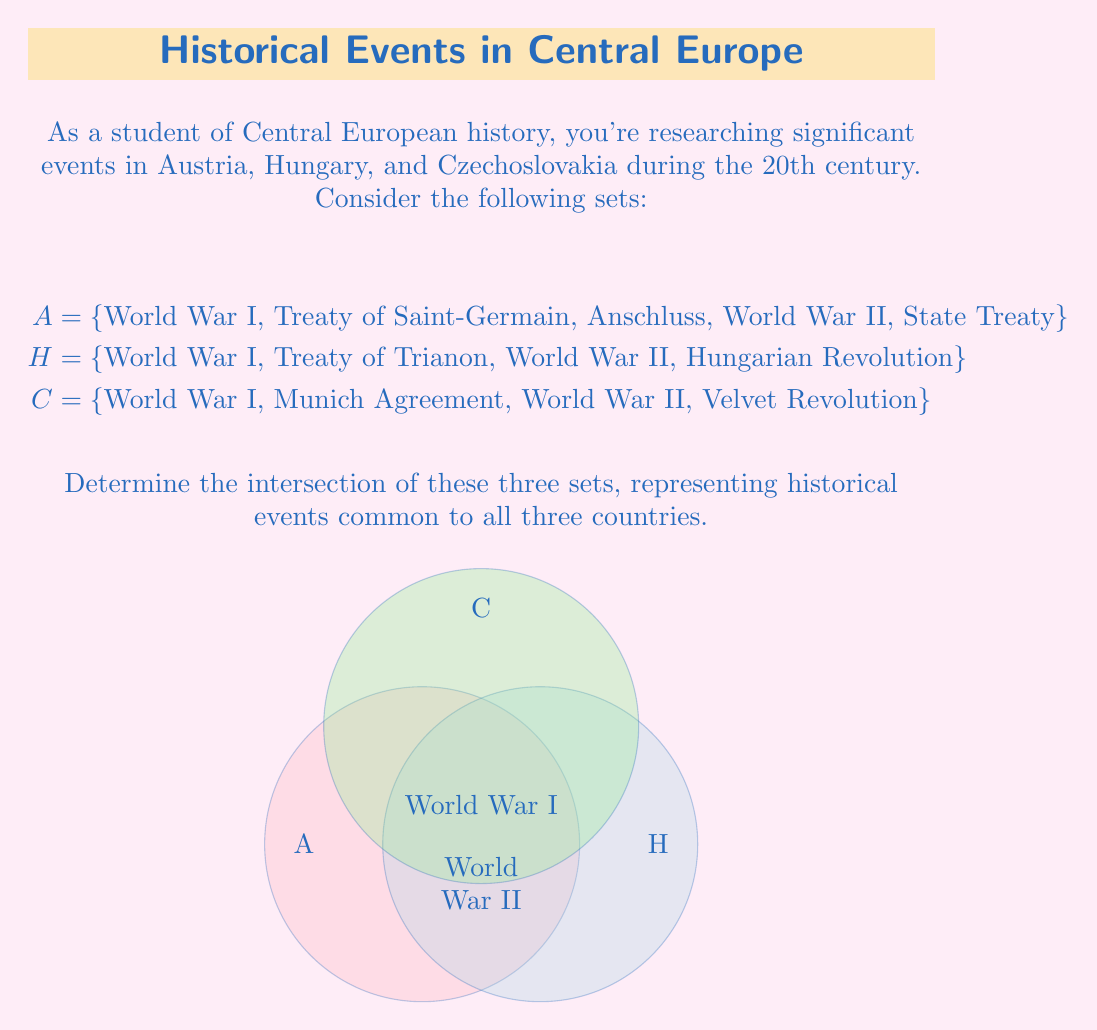Give your solution to this math problem. To find the intersection of these three sets, we need to identify the elements that are present in all three sets. Let's approach this step-by-step:

1. First, let's define the intersection operation:
   $A \cap H \cap C = \{x : x \in A \text{ and } x \in H \text{ and } x \in C\}$

2. Now, let's examine each element:

   a) World War I: Present in A, H, and C
   b) Treaty of Saint-Germain: Only in A
   c) Anschluss: Only in A
   d) World War II: Present in A, H, and C
   e) State Treaty: Only in A
   f) Treaty of Trianon: Only in H
   g) Hungarian Revolution: Only in H
   h) Munich Agreement: Only in C
   i) Velvet Revolution: Only in C

3. From this analysis, we can see that only two events are common to all three sets:
   World War I and World War II

4. Therefore, the intersection of these sets is:
   $A \cap H \cap C = \{\text{World War I}, \text{World War II}\}$

This result shows that these two major global conflicts were significant events that impacted all three Central European countries in the 20th century.
Answer: $\{\text{World War I}, \text{World War II}\}$ 